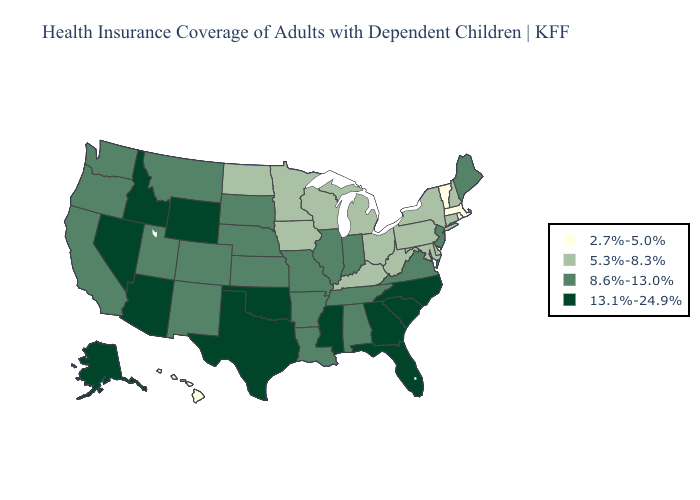What is the value of Louisiana?
Answer briefly. 8.6%-13.0%. Name the states that have a value in the range 13.1%-24.9%?
Answer briefly. Alaska, Arizona, Florida, Georgia, Idaho, Mississippi, Nevada, North Carolina, Oklahoma, South Carolina, Texas, Wyoming. Name the states that have a value in the range 8.6%-13.0%?
Answer briefly. Alabama, Arkansas, California, Colorado, Illinois, Indiana, Kansas, Louisiana, Maine, Missouri, Montana, Nebraska, New Jersey, New Mexico, Oregon, South Dakota, Tennessee, Utah, Virginia, Washington. Does Delaware have the lowest value in the South?
Give a very brief answer. Yes. What is the highest value in the Northeast ?
Answer briefly. 8.6%-13.0%. Does the first symbol in the legend represent the smallest category?
Concise answer only. Yes. What is the lowest value in the USA?
Be succinct. 2.7%-5.0%. Is the legend a continuous bar?
Be succinct. No. Name the states that have a value in the range 5.3%-8.3%?
Write a very short answer. Connecticut, Delaware, Iowa, Kentucky, Maryland, Michigan, Minnesota, New Hampshire, New York, North Dakota, Ohio, Pennsylvania, West Virginia, Wisconsin. What is the value of Georgia?
Quick response, please. 13.1%-24.9%. Does Indiana have a higher value than Wisconsin?
Keep it brief. Yes. Name the states that have a value in the range 8.6%-13.0%?
Give a very brief answer. Alabama, Arkansas, California, Colorado, Illinois, Indiana, Kansas, Louisiana, Maine, Missouri, Montana, Nebraska, New Jersey, New Mexico, Oregon, South Dakota, Tennessee, Utah, Virginia, Washington. Which states have the lowest value in the USA?
Concise answer only. Hawaii, Massachusetts, Rhode Island, Vermont. Name the states that have a value in the range 5.3%-8.3%?
Concise answer only. Connecticut, Delaware, Iowa, Kentucky, Maryland, Michigan, Minnesota, New Hampshire, New York, North Dakota, Ohio, Pennsylvania, West Virginia, Wisconsin. What is the value of Michigan?
Keep it brief. 5.3%-8.3%. 